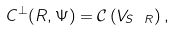Convert formula to latex. <formula><loc_0><loc_0><loc_500><loc_500>C ^ { \perp } ( R , \Psi ) = \mathcal { C } \left ( V _ { S \ R } \right ) ,</formula> 